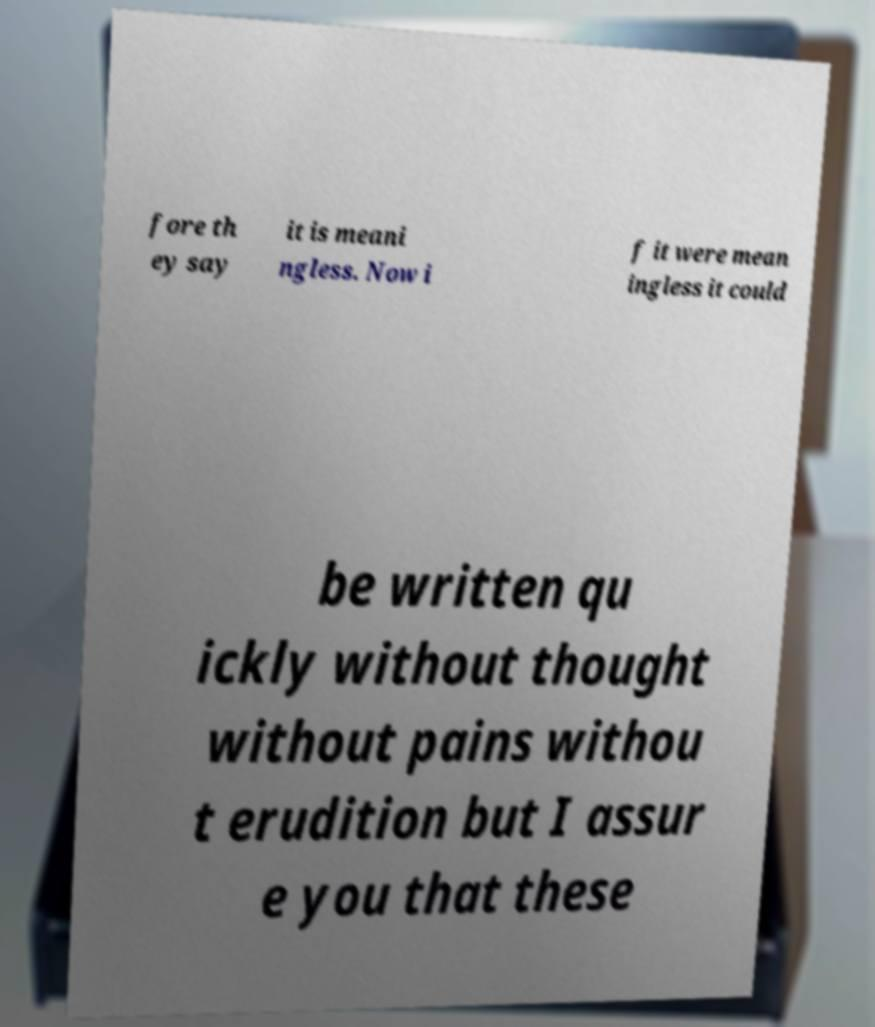There's text embedded in this image that I need extracted. Can you transcribe it verbatim? fore th ey say it is meani ngless. Now i f it were mean ingless it could be written qu ickly without thought without pains withou t erudition but I assur e you that these 